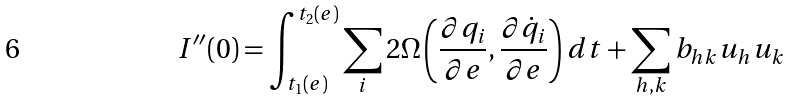Convert formula to latex. <formula><loc_0><loc_0><loc_500><loc_500>I ^ { \prime \prime } ( 0 ) = \int _ { t _ { 1 } ( e ) } ^ { t _ { 2 } ( e ) } \sum _ { i } 2 \Omega \left ( \frac { \partial q _ { i } } { \partial e } , \frac { \partial \dot { q } _ { i } } { \partial e } \right ) d t + \sum _ { h , k } b _ { h k } u _ { h } u _ { k }</formula> 